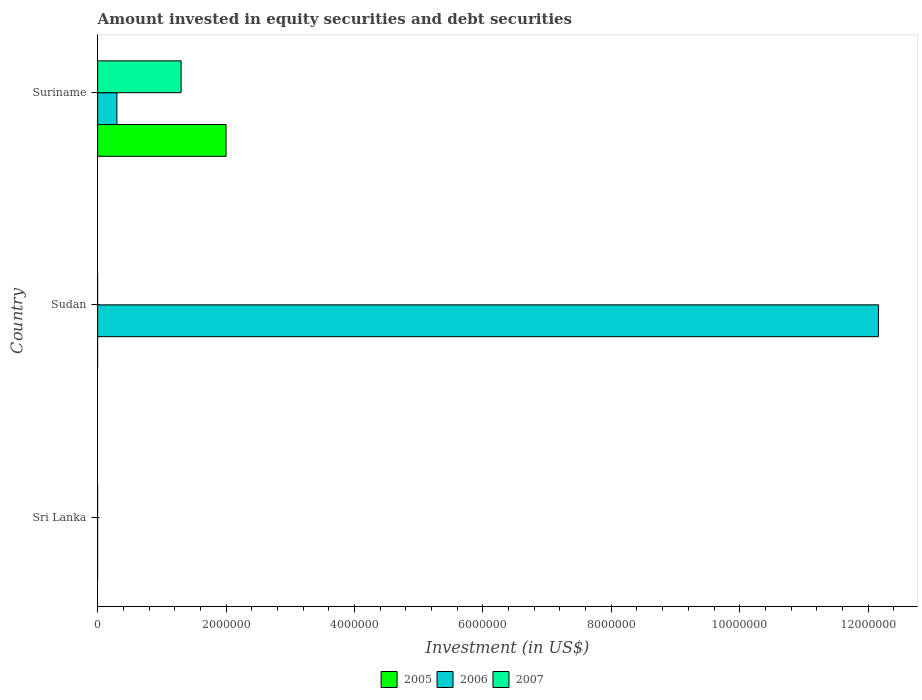Are the number of bars per tick equal to the number of legend labels?
Offer a terse response. No. How many bars are there on the 1st tick from the bottom?
Your answer should be compact. 0. What is the label of the 1st group of bars from the top?
Keep it short and to the point. Suriname. In how many cases, is the number of bars for a given country not equal to the number of legend labels?
Offer a very short reply. 2. What is the amount invested in equity securities and debt securities in 2005 in Suriname?
Make the answer very short. 2.00e+06. Across all countries, what is the maximum amount invested in equity securities and debt securities in 2005?
Your response must be concise. 2.00e+06. In which country was the amount invested in equity securities and debt securities in 2007 maximum?
Your answer should be very brief. Suriname. What is the total amount invested in equity securities and debt securities in 2006 in the graph?
Provide a short and direct response. 1.25e+07. What is the difference between the amount invested in equity securities and debt securities in 2006 in Sri Lanka and the amount invested in equity securities and debt securities in 2005 in Sudan?
Make the answer very short. 0. What is the average amount invested in equity securities and debt securities in 2006 per country?
Offer a very short reply. 4.15e+06. What is the difference between the amount invested in equity securities and debt securities in 2007 and amount invested in equity securities and debt securities in 2005 in Suriname?
Your response must be concise. -7.00e+05. In how many countries, is the amount invested in equity securities and debt securities in 2005 greater than 800000 US$?
Keep it short and to the point. 1. What is the ratio of the amount invested in equity securities and debt securities in 2006 in Sudan to that in Suriname?
Give a very brief answer. 40.54. Is the amount invested in equity securities and debt securities in 2006 in Sudan less than that in Suriname?
Ensure brevity in your answer.  No. What is the difference between the highest and the lowest amount invested in equity securities and debt securities in 2007?
Your answer should be very brief. 1.30e+06. Are all the bars in the graph horizontal?
Offer a very short reply. Yes. How many countries are there in the graph?
Keep it short and to the point. 3. Does the graph contain any zero values?
Keep it short and to the point. Yes. Where does the legend appear in the graph?
Provide a succinct answer. Bottom center. What is the title of the graph?
Keep it short and to the point. Amount invested in equity securities and debt securities. What is the label or title of the X-axis?
Keep it short and to the point. Investment (in US$). What is the Investment (in US$) of 2007 in Sri Lanka?
Keep it short and to the point. 0. What is the Investment (in US$) of 2006 in Sudan?
Provide a short and direct response. 1.22e+07. What is the Investment (in US$) in 2007 in Sudan?
Your answer should be compact. 0. What is the Investment (in US$) in 2007 in Suriname?
Make the answer very short. 1.30e+06. Across all countries, what is the maximum Investment (in US$) of 2005?
Keep it short and to the point. 2.00e+06. Across all countries, what is the maximum Investment (in US$) in 2006?
Make the answer very short. 1.22e+07. Across all countries, what is the maximum Investment (in US$) of 2007?
Keep it short and to the point. 1.30e+06. Across all countries, what is the minimum Investment (in US$) of 2005?
Offer a very short reply. 0. Across all countries, what is the minimum Investment (in US$) of 2006?
Offer a terse response. 0. Across all countries, what is the minimum Investment (in US$) of 2007?
Offer a very short reply. 0. What is the total Investment (in US$) of 2006 in the graph?
Offer a terse response. 1.25e+07. What is the total Investment (in US$) of 2007 in the graph?
Provide a succinct answer. 1.30e+06. What is the difference between the Investment (in US$) in 2006 in Sudan and that in Suriname?
Make the answer very short. 1.19e+07. What is the difference between the Investment (in US$) of 2006 in Sudan and the Investment (in US$) of 2007 in Suriname?
Your response must be concise. 1.09e+07. What is the average Investment (in US$) of 2005 per country?
Make the answer very short. 6.67e+05. What is the average Investment (in US$) in 2006 per country?
Provide a succinct answer. 4.15e+06. What is the average Investment (in US$) of 2007 per country?
Provide a short and direct response. 4.33e+05. What is the difference between the Investment (in US$) in 2005 and Investment (in US$) in 2006 in Suriname?
Your response must be concise. 1.70e+06. What is the difference between the Investment (in US$) in 2005 and Investment (in US$) in 2007 in Suriname?
Make the answer very short. 7.00e+05. What is the ratio of the Investment (in US$) of 2006 in Sudan to that in Suriname?
Ensure brevity in your answer.  40.54. What is the difference between the highest and the lowest Investment (in US$) in 2005?
Give a very brief answer. 2.00e+06. What is the difference between the highest and the lowest Investment (in US$) of 2006?
Keep it short and to the point. 1.22e+07. What is the difference between the highest and the lowest Investment (in US$) of 2007?
Your response must be concise. 1.30e+06. 